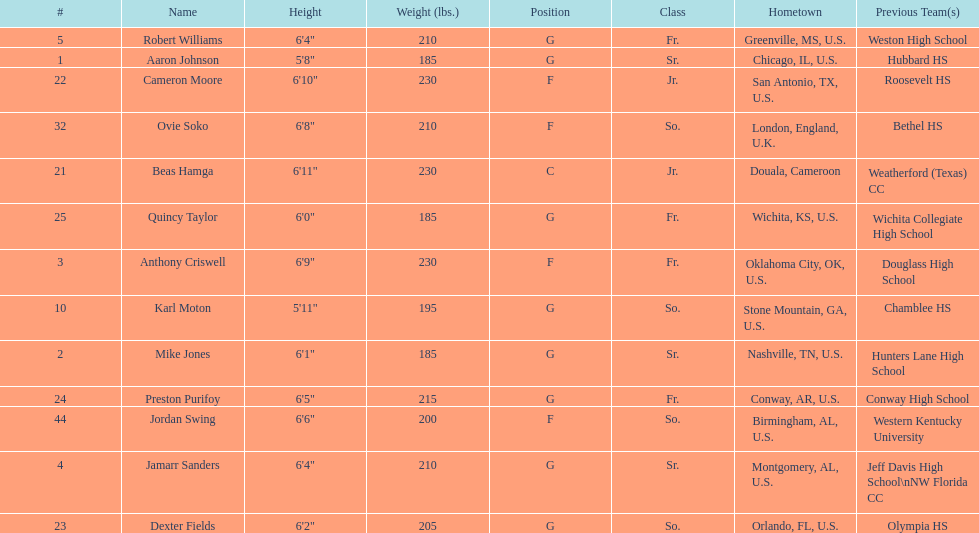What was the number of players on the 2010-11 uab blazers men's basketball team? 13. 